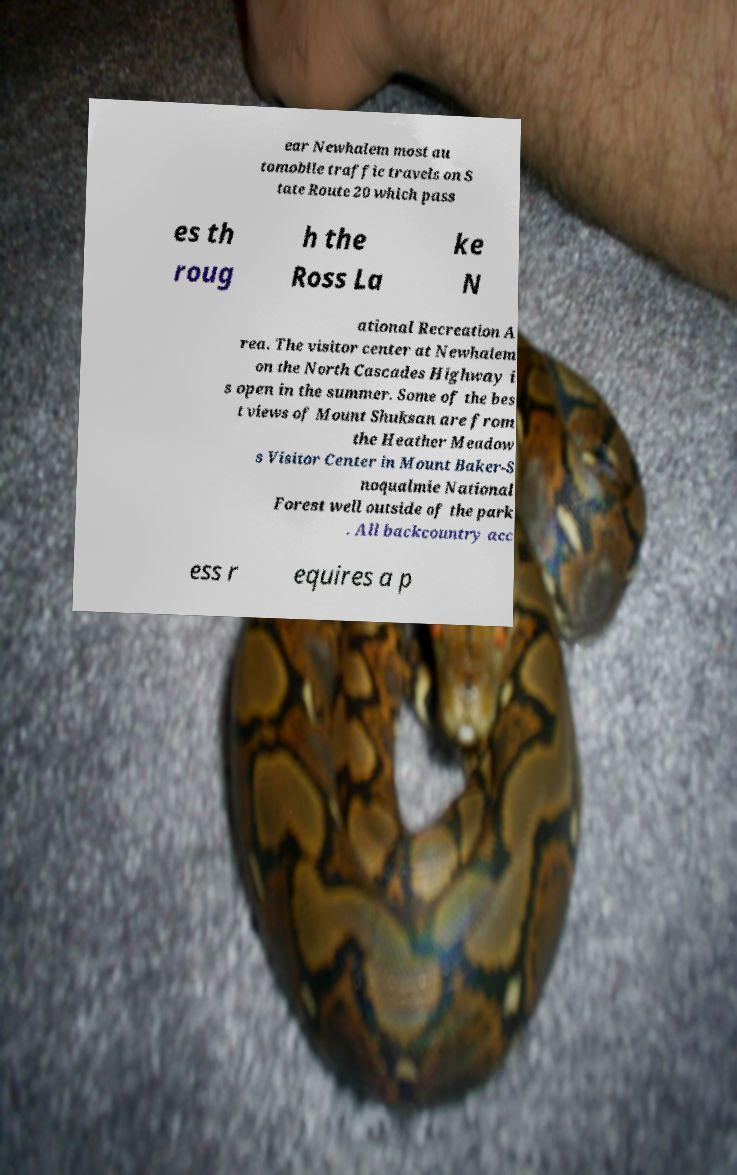For documentation purposes, I need the text within this image transcribed. Could you provide that? ear Newhalem most au tomobile traffic travels on S tate Route 20 which pass es th roug h the Ross La ke N ational Recreation A rea. The visitor center at Newhalem on the North Cascades Highway i s open in the summer. Some of the bes t views of Mount Shuksan are from the Heather Meadow s Visitor Center in Mount Baker-S noqualmie National Forest well outside of the park . All backcountry acc ess r equires a p 